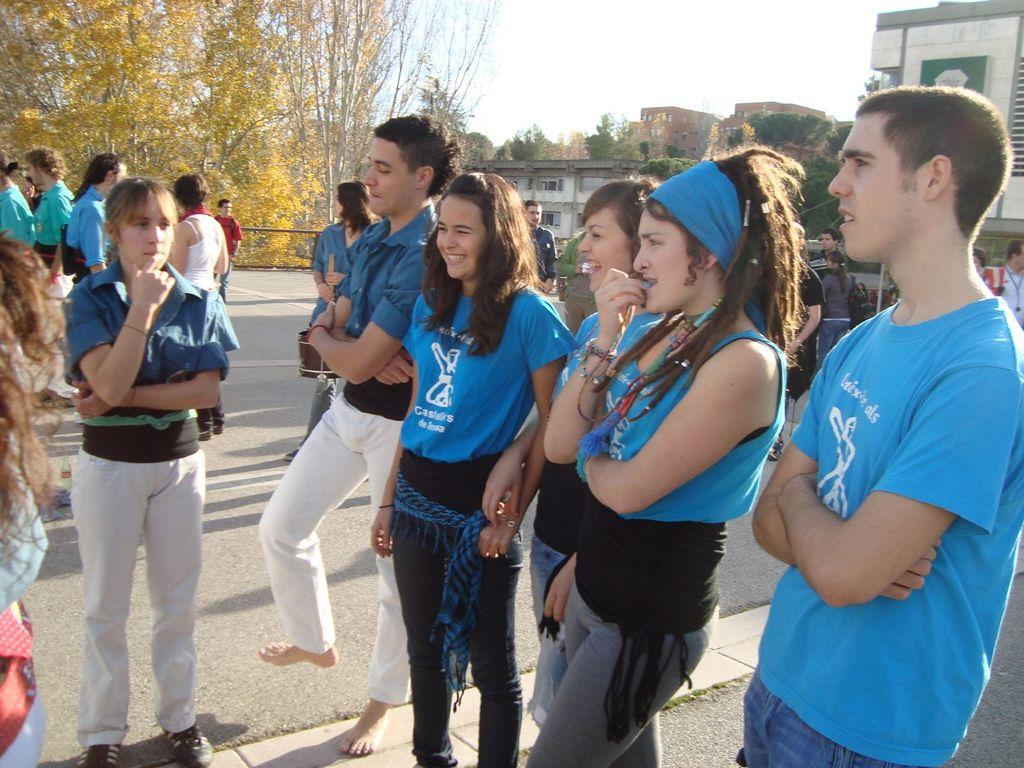What color are the dresses worn by the people in the image? The people are wearing blue color dresses in the image. Where are the people standing in the image? The people are standing on the road in the image. Can you describe the background of the image? In the background of the image, there are more people, houses, trees, and the sky visible. What type of bead is being sold in the store visible in the image? There is no store visible in the image, so it is not possible to determine what type of bead might be sold there. --- 